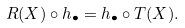<formula> <loc_0><loc_0><loc_500><loc_500>R ( X ) \circ h _ { \bullet } = h _ { \bullet } \circ T ( X ) .</formula> 